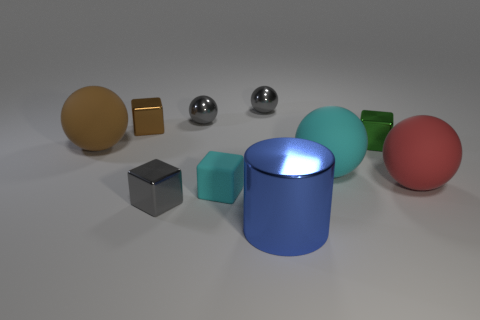Is the material of the big blue cylinder the same as the gray object that is in front of the large red ball?
Your answer should be compact. Yes. Are there more gray cubes that are behind the red thing than large metallic blocks?
Make the answer very short. No. The big rubber object that is the same color as the tiny rubber block is what shape?
Your answer should be very brief. Sphere. Are there any large red objects made of the same material as the brown cube?
Ensure brevity in your answer.  No. Are the brown object that is behind the big brown thing and the tiny object that is in front of the tiny cyan thing made of the same material?
Give a very brief answer. Yes. Is the number of large red things that are behind the cyan ball the same as the number of small matte blocks that are right of the large blue metal object?
Provide a short and direct response. Yes. What is the color of the rubber cube that is the same size as the green metal object?
Keep it short and to the point. Cyan. Is there a small matte block of the same color as the small rubber thing?
Your response must be concise. No. What number of things are either tiny metallic blocks that are to the left of the big blue metal cylinder or shiny cylinders?
Ensure brevity in your answer.  3. How many other objects are there of the same size as the gray cube?
Keep it short and to the point. 5. 